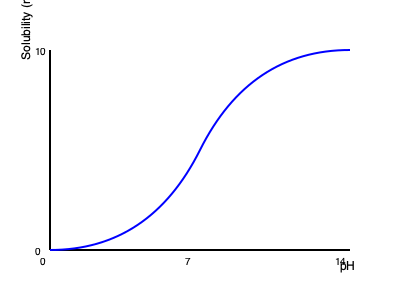Based on the pH-solubility profile shown in the graph, determine the pKa of the drug compound and explain whether it is likely to be an acidic or basic drug. How would this profile influence the drug's absorption in different parts of the gastrointestinal tract? To answer this question, we need to analyze the pH-solubility profile:

1. Identify the pKa:
   The pKa is the pH at which the solubility curve shows an inflection point. In this graph, the inflection point occurs around pH 7.

2. Determine if the drug is acidic or basic:
   The solubility increases as pH increases, which is characteristic of weak acids. Weak acids are more soluble in their ionized form at higher pH values.

3. Influence on gastrointestinal absorption:
   a) Stomach (pH 1-3): The drug will have low solubility, limiting absorption.
   b) Small intestine (pH 6-7): Solubility increases, enhancing absorption.
   c) Large intestine (pH 7-8): Highest solubility, but limited absorption due to reduced surface area.

4. Impact on drug development:
   - Formulation strategies may be needed to improve solubility in acidic environments.
   - Enteric coatings could be considered to protect the drug from stomach acid.
   - Extended-release formulations might be beneficial to utilize the higher solubility in the intestines.

The pKa value of approximately 7 suggests that the drug is a weak acid with balanced ionization at physiological pH, which can affect its membrane permeability and overall bioavailability.
Answer: pKa ≈ 7; weak acid; higher absorption in intestines than stomach due to pH-dependent solubility. 